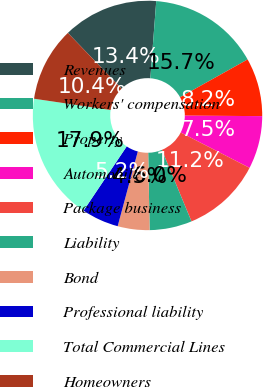<chart> <loc_0><loc_0><loc_500><loc_500><pie_chart><fcel>Revenues<fcel>Workers' compensation<fcel>Property<fcel>Automobile<fcel>Package business<fcel>Liability<fcel>Bond<fcel>Professional liability<fcel>Total Commercial Lines<fcel>Homeowners<nl><fcel>13.43%<fcel>15.67%<fcel>8.21%<fcel>7.46%<fcel>11.19%<fcel>5.97%<fcel>4.48%<fcel>5.23%<fcel>17.91%<fcel>10.45%<nl></chart> 